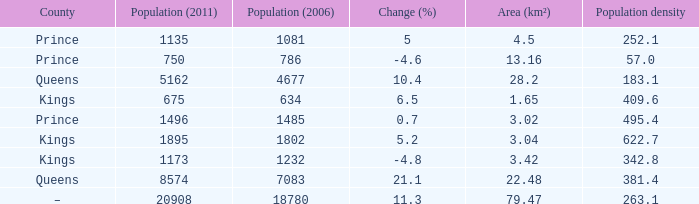What was the Area (km²) when the Population (2011) was 8574, and the Population density was larger than 381.4? None. 